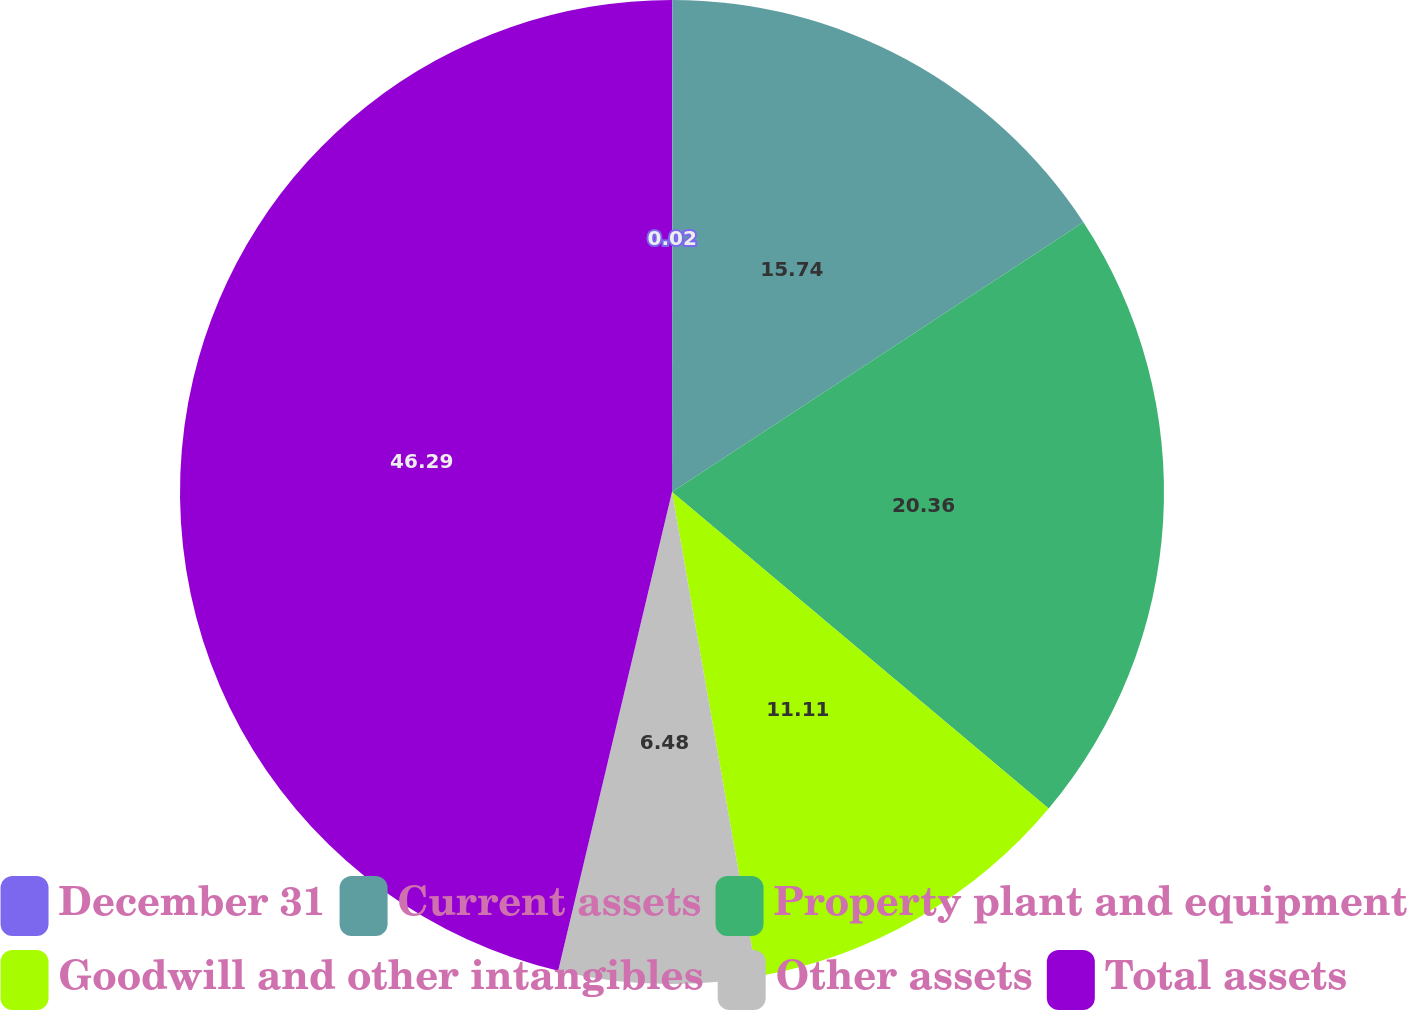Convert chart. <chart><loc_0><loc_0><loc_500><loc_500><pie_chart><fcel>December 31<fcel>Current assets<fcel>Property plant and equipment<fcel>Goodwill and other intangibles<fcel>Other assets<fcel>Total assets<nl><fcel>0.02%<fcel>15.74%<fcel>20.36%<fcel>11.11%<fcel>6.48%<fcel>46.28%<nl></chart> 